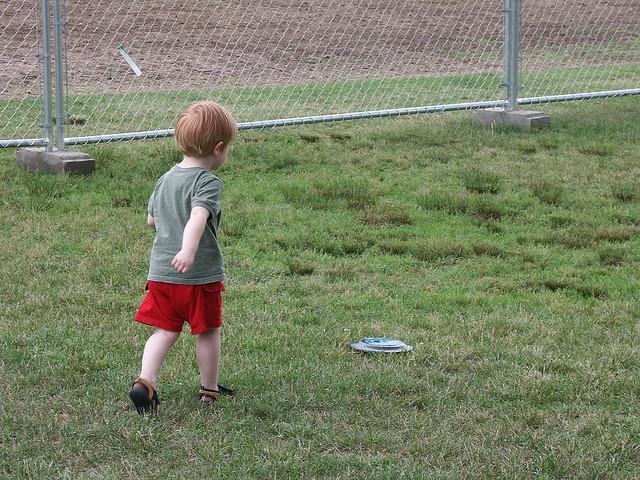What color hair does the child have?
Write a very short answer. Red. What color are his shorts?
Be succinct. Red. What color shirt is the boy wearing?
Short answer required. Green. Is the fence touching the ground?
Keep it brief. No. Is this boy afraid of frisbee?
Quick response, please. No. What is the boy getting ready to do?
Write a very short answer. Pick up frisbee. What color shoes is the boy wearing?
Short answer required. Black. What is the boy doing?
Short answer required. Walking. What color is the boy's hair?
Write a very short answer. Red. What color is the kid's outfit?
Answer briefly. Green and red. 